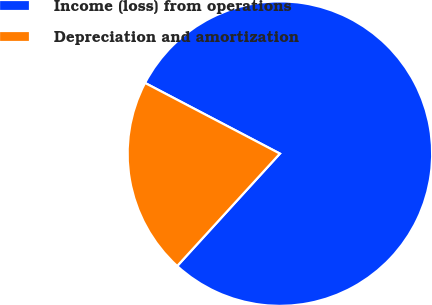Convert chart. <chart><loc_0><loc_0><loc_500><loc_500><pie_chart><fcel>Income (loss) from operations<fcel>Depreciation and amortization<nl><fcel>79.1%<fcel>20.9%<nl></chart> 